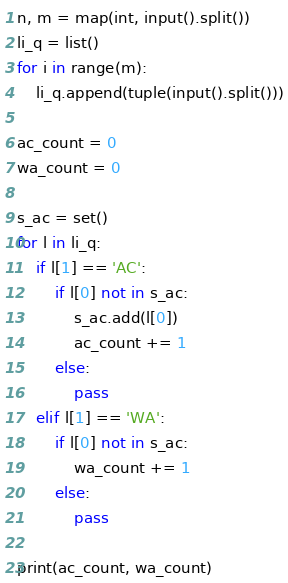Convert code to text. <code><loc_0><loc_0><loc_500><loc_500><_Python_>n, m = map(int, input().split())
li_q = list()
for i in range(m):
    li_q.append(tuple(input().split()))

ac_count = 0
wa_count = 0

s_ac = set()
for l in li_q:
    if l[1] == 'AC':
        if l[0] not in s_ac:
            s_ac.add(l[0])
            ac_count += 1
        else:
            pass
    elif l[1] == 'WA':
        if l[0] not in s_ac:
            wa_count += 1
        else:
            pass

print(ac_count, wa_count)
</code> 